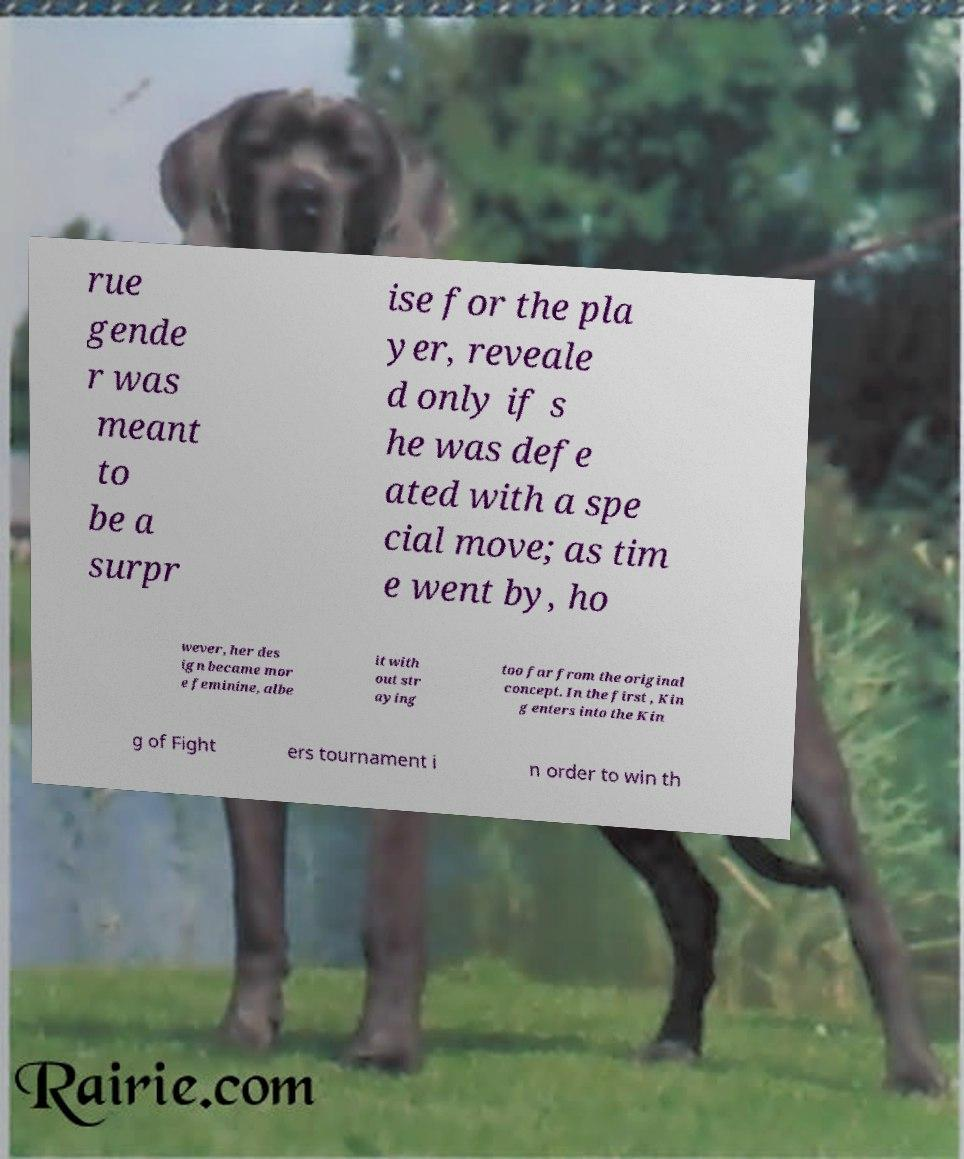For documentation purposes, I need the text within this image transcribed. Could you provide that? rue gende r was meant to be a surpr ise for the pla yer, reveale d only if s he was defe ated with a spe cial move; as tim e went by, ho wever, her des ign became mor e feminine, albe it with out str aying too far from the original concept. In the first , Kin g enters into the Kin g of Fight ers tournament i n order to win th 